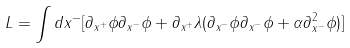Convert formula to latex. <formula><loc_0><loc_0><loc_500><loc_500>L = \int d x ^ { - } [ \partial _ { x ^ { + } } \phi \partial _ { x ^ { - } } \phi + \partial _ { x ^ { + } } \lambda ( \partial _ { x ^ { - } } \phi \partial _ { x ^ { - } } \phi + \alpha \partial _ { x ^ { - } } ^ { 2 } \phi ) ]</formula> 